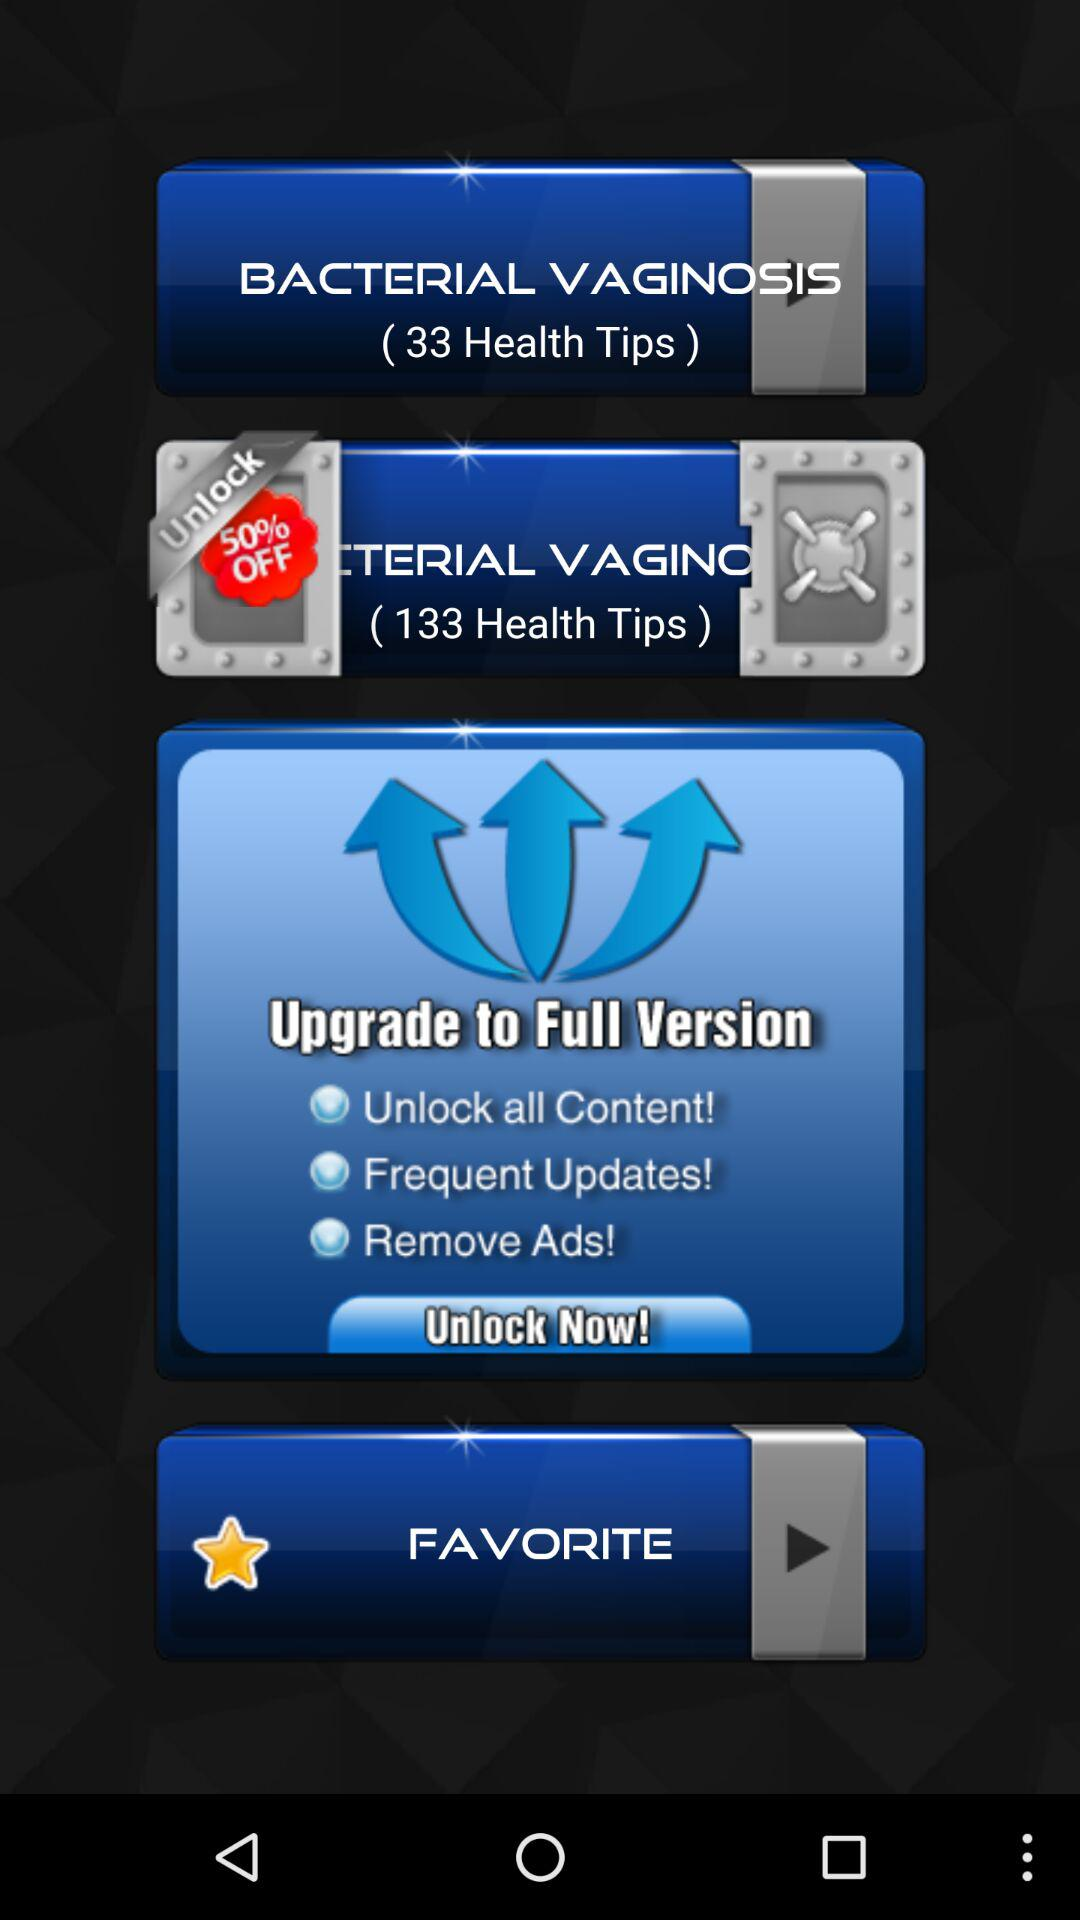How many health tips are there for bacterial vaginosis to unlock with the offer? There are 133 health tips for bacterial vaginosis to unlock with the offer. 